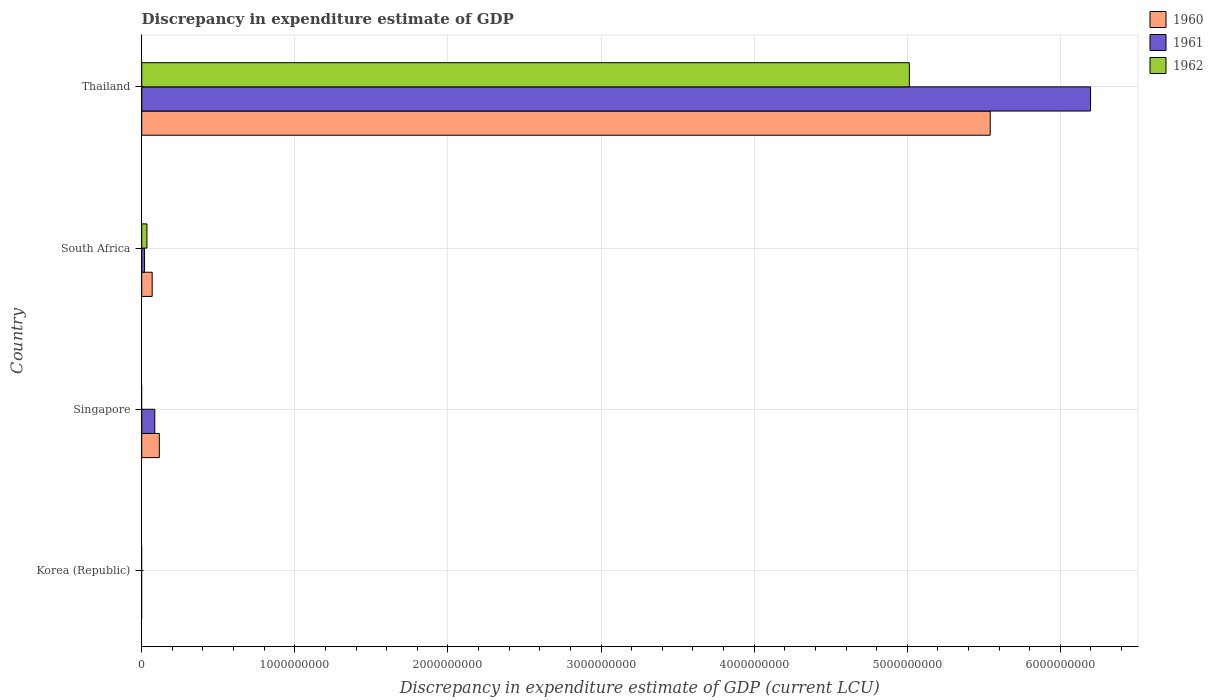Are the number of bars per tick equal to the number of legend labels?
Provide a short and direct response. No. How many bars are there on the 2nd tick from the top?
Provide a short and direct response. 3. What is the label of the 4th group of bars from the top?
Provide a short and direct response. Korea (Republic). What is the discrepancy in expenditure estimate of GDP in 1961 in South Africa?
Provide a short and direct response. 1.84e+07. Across all countries, what is the maximum discrepancy in expenditure estimate of GDP in 1961?
Keep it short and to the point. 6.20e+09. In which country was the discrepancy in expenditure estimate of GDP in 1960 maximum?
Provide a short and direct response. Thailand. What is the total discrepancy in expenditure estimate of GDP in 1962 in the graph?
Make the answer very short. 5.05e+09. What is the difference between the discrepancy in expenditure estimate of GDP in 1961 in Singapore and that in Thailand?
Provide a succinct answer. -6.11e+09. What is the difference between the discrepancy in expenditure estimate of GDP in 1960 in Thailand and the discrepancy in expenditure estimate of GDP in 1962 in Singapore?
Your response must be concise. 5.54e+09. What is the average discrepancy in expenditure estimate of GDP in 1961 per country?
Make the answer very short. 1.58e+09. What is the difference between the discrepancy in expenditure estimate of GDP in 1960 and discrepancy in expenditure estimate of GDP in 1962 in South Africa?
Your answer should be compact. 3.43e+07. What is the ratio of the discrepancy in expenditure estimate of GDP in 1961 in South Africa to that in Thailand?
Your answer should be compact. 0. What is the difference between the highest and the second highest discrepancy in expenditure estimate of GDP in 1960?
Keep it short and to the point. 5.43e+09. What is the difference between the highest and the lowest discrepancy in expenditure estimate of GDP in 1961?
Ensure brevity in your answer.  6.20e+09. Are all the bars in the graph horizontal?
Make the answer very short. Yes. How many countries are there in the graph?
Give a very brief answer. 4. What is the difference between two consecutive major ticks on the X-axis?
Your answer should be very brief. 1.00e+09. Does the graph contain any zero values?
Keep it short and to the point. Yes. Does the graph contain grids?
Your answer should be very brief. Yes. How are the legend labels stacked?
Provide a succinct answer. Vertical. What is the title of the graph?
Make the answer very short. Discrepancy in expenditure estimate of GDP. What is the label or title of the X-axis?
Make the answer very short. Discrepancy in expenditure estimate of GDP (current LCU). What is the label or title of the Y-axis?
Ensure brevity in your answer.  Country. What is the Discrepancy in expenditure estimate of GDP (current LCU) of 1960 in Korea (Republic)?
Your answer should be very brief. 0. What is the Discrepancy in expenditure estimate of GDP (current LCU) of 1961 in Korea (Republic)?
Your response must be concise. 0. What is the Discrepancy in expenditure estimate of GDP (current LCU) of 1960 in Singapore?
Provide a succinct answer. 1.15e+08. What is the Discrepancy in expenditure estimate of GDP (current LCU) of 1961 in Singapore?
Offer a terse response. 8.53e+07. What is the Discrepancy in expenditure estimate of GDP (current LCU) of 1960 in South Africa?
Offer a very short reply. 6.83e+07. What is the Discrepancy in expenditure estimate of GDP (current LCU) of 1961 in South Africa?
Keep it short and to the point. 1.84e+07. What is the Discrepancy in expenditure estimate of GDP (current LCU) in 1962 in South Africa?
Offer a terse response. 3.40e+07. What is the Discrepancy in expenditure estimate of GDP (current LCU) of 1960 in Thailand?
Your answer should be compact. 5.54e+09. What is the Discrepancy in expenditure estimate of GDP (current LCU) in 1961 in Thailand?
Give a very brief answer. 6.20e+09. What is the Discrepancy in expenditure estimate of GDP (current LCU) in 1962 in Thailand?
Your answer should be compact. 5.01e+09. Across all countries, what is the maximum Discrepancy in expenditure estimate of GDP (current LCU) in 1960?
Keep it short and to the point. 5.54e+09. Across all countries, what is the maximum Discrepancy in expenditure estimate of GDP (current LCU) of 1961?
Ensure brevity in your answer.  6.20e+09. Across all countries, what is the maximum Discrepancy in expenditure estimate of GDP (current LCU) of 1962?
Make the answer very short. 5.01e+09. Across all countries, what is the minimum Discrepancy in expenditure estimate of GDP (current LCU) of 1960?
Make the answer very short. 0. Across all countries, what is the minimum Discrepancy in expenditure estimate of GDP (current LCU) of 1961?
Keep it short and to the point. 0. What is the total Discrepancy in expenditure estimate of GDP (current LCU) of 1960 in the graph?
Ensure brevity in your answer.  5.72e+09. What is the total Discrepancy in expenditure estimate of GDP (current LCU) in 1961 in the graph?
Give a very brief answer. 6.30e+09. What is the total Discrepancy in expenditure estimate of GDP (current LCU) of 1962 in the graph?
Provide a succinct answer. 5.05e+09. What is the difference between the Discrepancy in expenditure estimate of GDP (current LCU) in 1960 in Singapore and that in South Africa?
Offer a terse response. 4.66e+07. What is the difference between the Discrepancy in expenditure estimate of GDP (current LCU) in 1961 in Singapore and that in South Africa?
Offer a very short reply. 6.69e+07. What is the difference between the Discrepancy in expenditure estimate of GDP (current LCU) in 1960 in Singapore and that in Thailand?
Offer a very short reply. -5.43e+09. What is the difference between the Discrepancy in expenditure estimate of GDP (current LCU) in 1961 in Singapore and that in Thailand?
Give a very brief answer. -6.11e+09. What is the difference between the Discrepancy in expenditure estimate of GDP (current LCU) of 1960 in South Africa and that in Thailand?
Give a very brief answer. -5.47e+09. What is the difference between the Discrepancy in expenditure estimate of GDP (current LCU) of 1961 in South Africa and that in Thailand?
Your response must be concise. -6.18e+09. What is the difference between the Discrepancy in expenditure estimate of GDP (current LCU) of 1962 in South Africa and that in Thailand?
Ensure brevity in your answer.  -4.98e+09. What is the difference between the Discrepancy in expenditure estimate of GDP (current LCU) in 1960 in Singapore and the Discrepancy in expenditure estimate of GDP (current LCU) in 1961 in South Africa?
Keep it short and to the point. 9.65e+07. What is the difference between the Discrepancy in expenditure estimate of GDP (current LCU) of 1960 in Singapore and the Discrepancy in expenditure estimate of GDP (current LCU) of 1962 in South Africa?
Provide a short and direct response. 8.09e+07. What is the difference between the Discrepancy in expenditure estimate of GDP (current LCU) in 1961 in Singapore and the Discrepancy in expenditure estimate of GDP (current LCU) in 1962 in South Africa?
Offer a very short reply. 5.13e+07. What is the difference between the Discrepancy in expenditure estimate of GDP (current LCU) in 1960 in Singapore and the Discrepancy in expenditure estimate of GDP (current LCU) in 1961 in Thailand?
Make the answer very short. -6.08e+09. What is the difference between the Discrepancy in expenditure estimate of GDP (current LCU) of 1960 in Singapore and the Discrepancy in expenditure estimate of GDP (current LCU) of 1962 in Thailand?
Make the answer very short. -4.90e+09. What is the difference between the Discrepancy in expenditure estimate of GDP (current LCU) in 1961 in Singapore and the Discrepancy in expenditure estimate of GDP (current LCU) in 1962 in Thailand?
Make the answer very short. -4.93e+09. What is the difference between the Discrepancy in expenditure estimate of GDP (current LCU) in 1960 in South Africa and the Discrepancy in expenditure estimate of GDP (current LCU) in 1961 in Thailand?
Give a very brief answer. -6.13e+09. What is the difference between the Discrepancy in expenditure estimate of GDP (current LCU) in 1960 in South Africa and the Discrepancy in expenditure estimate of GDP (current LCU) in 1962 in Thailand?
Your answer should be compact. -4.95e+09. What is the difference between the Discrepancy in expenditure estimate of GDP (current LCU) of 1961 in South Africa and the Discrepancy in expenditure estimate of GDP (current LCU) of 1962 in Thailand?
Ensure brevity in your answer.  -5.00e+09. What is the average Discrepancy in expenditure estimate of GDP (current LCU) of 1960 per country?
Offer a terse response. 1.43e+09. What is the average Discrepancy in expenditure estimate of GDP (current LCU) in 1961 per country?
Make the answer very short. 1.58e+09. What is the average Discrepancy in expenditure estimate of GDP (current LCU) of 1962 per country?
Your response must be concise. 1.26e+09. What is the difference between the Discrepancy in expenditure estimate of GDP (current LCU) of 1960 and Discrepancy in expenditure estimate of GDP (current LCU) of 1961 in Singapore?
Your answer should be very brief. 2.96e+07. What is the difference between the Discrepancy in expenditure estimate of GDP (current LCU) of 1960 and Discrepancy in expenditure estimate of GDP (current LCU) of 1961 in South Africa?
Provide a short and direct response. 4.99e+07. What is the difference between the Discrepancy in expenditure estimate of GDP (current LCU) in 1960 and Discrepancy in expenditure estimate of GDP (current LCU) in 1962 in South Africa?
Keep it short and to the point. 3.43e+07. What is the difference between the Discrepancy in expenditure estimate of GDP (current LCU) in 1961 and Discrepancy in expenditure estimate of GDP (current LCU) in 1962 in South Africa?
Provide a short and direct response. -1.56e+07. What is the difference between the Discrepancy in expenditure estimate of GDP (current LCU) of 1960 and Discrepancy in expenditure estimate of GDP (current LCU) of 1961 in Thailand?
Keep it short and to the point. -6.56e+08. What is the difference between the Discrepancy in expenditure estimate of GDP (current LCU) in 1960 and Discrepancy in expenditure estimate of GDP (current LCU) in 1962 in Thailand?
Offer a terse response. 5.28e+08. What is the difference between the Discrepancy in expenditure estimate of GDP (current LCU) of 1961 and Discrepancy in expenditure estimate of GDP (current LCU) of 1962 in Thailand?
Provide a short and direct response. 1.18e+09. What is the ratio of the Discrepancy in expenditure estimate of GDP (current LCU) in 1960 in Singapore to that in South Africa?
Offer a very short reply. 1.68. What is the ratio of the Discrepancy in expenditure estimate of GDP (current LCU) in 1961 in Singapore to that in South Africa?
Provide a short and direct response. 4.64. What is the ratio of the Discrepancy in expenditure estimate of GDP (current LCU) in 1960 in Singapore to that in Thailand?
Your answer should be compact. 0.02. What is the ratio of the Discrepancy in expenditure estimate of GDP (current LCU) in 1961 in Singapore to that in Thailand?
Give a very brief answer. 0.01. What is the ratio of the Discrepancy in expenditure estimate of GDP (current LCU) in 1960 in South Africa to that in Thailand?
Provide a succinct answer. 0.01. What is the ratio of the Discrepancy in expenditure estimate of GDP (current LCU) in 1961 in South Africa to that in Thailand?
Your response must be concise. 0. What is the ratio of the Discrepancy in expenditure estimate of GDP (current LCU) of 1962 in South Africa to that in Thailand?
Offer a very short reply. 0.01. What is the difference between the highest and the second highest Discrepancy in expenditure estimate of GDP (current LCU) in 1960?
Offer a terse response. 5.43e+09. What is the difference between the highest and the second highest Discrepancy in expenditure estimate of GDP (current LCU) of 1961?
Ensure brevity in your answer.  6.11e+09. What is the difference between the highest and the lowest Discrepancy in expenditure estimate of GDP (current LCU) of 1960?
Provide a succinct answer. 5.54e+09. What is the difference between the highest and the lowest Discrepancy in expenditure estimate of GDP (current LCU) of 1961?
Ensure brevity in your answer.  6.20e+09. What is the difference between the highest and the lowest Discrepancy in expenditure estimate of GDP (current LCU) of 1962?
Your answer should be compact. 5.01e+09. 